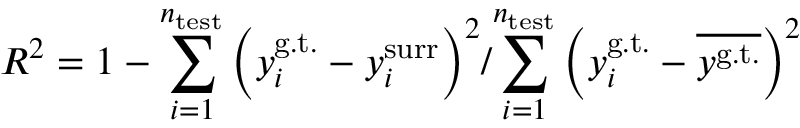<formula> <loc_0><loc_0><loc_500><loc_500>R ^ { 2 } = 1 - { \sum _ { i = 1 } ^ { n _ { t e s t } } \left ( y _ { i } ^ { g . t . } - y _ { i } ^ { s u r r } \right ) ^ { 2 } } / { \sum _ { i = 1 } ^ { n _ { t e s t } } \left ( y _ { i } ^ { g . t . } - { \overline { { y ^ { g . t . } } } } \right ) ^ { 2 } }</formula> 